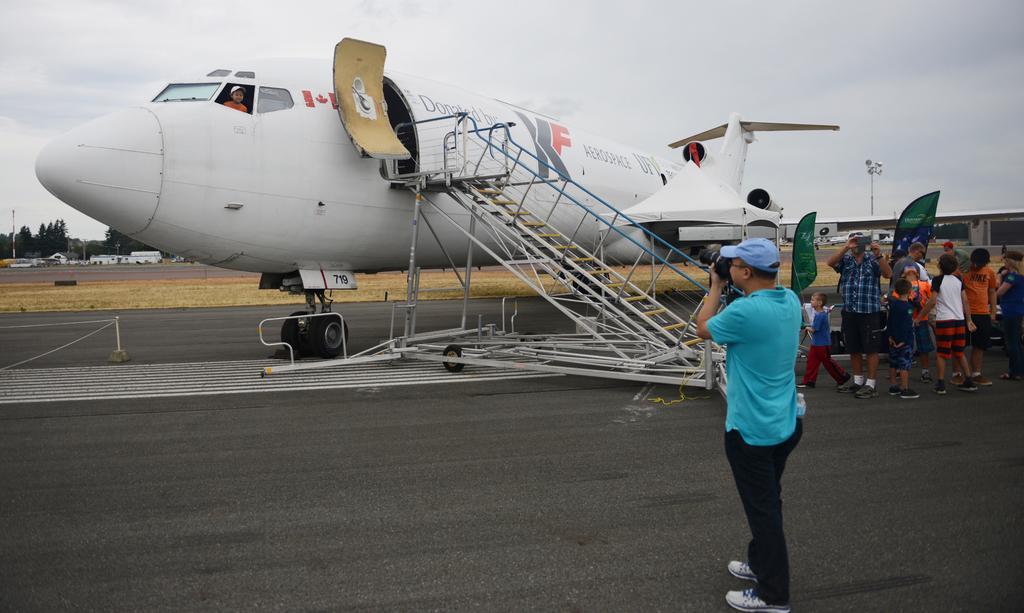Describe this image in one or two sentences. In this image we can see a person taking a photograph by a camera of a child who is standing near the window of an aeroplane. On the right side we can see a person standing holding a camera and some children walking on the road. We can also see a pole and a house. On the left side we can see rope to a pole, trees, house with roof and the sky which looks cloudy. 